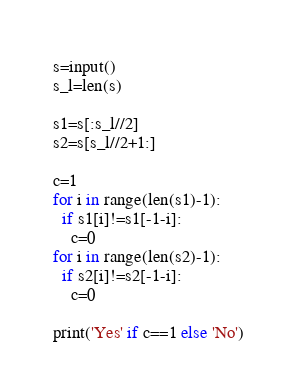<code> <loc_0><loc_0><loc_500><loc_500><_Python_>s=input()
s_l=len(s)

s1=s[:s_l//2]
s2=s[s_l//2+1:]

c=1
for i in range(len(s1)-1):
  if s1[i]!=s1[-1-i]:
    c=0
for i in range(len(s2)-1):
  if s2[i]!=s2[-1-i]:
    c=0

print('Yes' if c==1 else 'No')</code> 